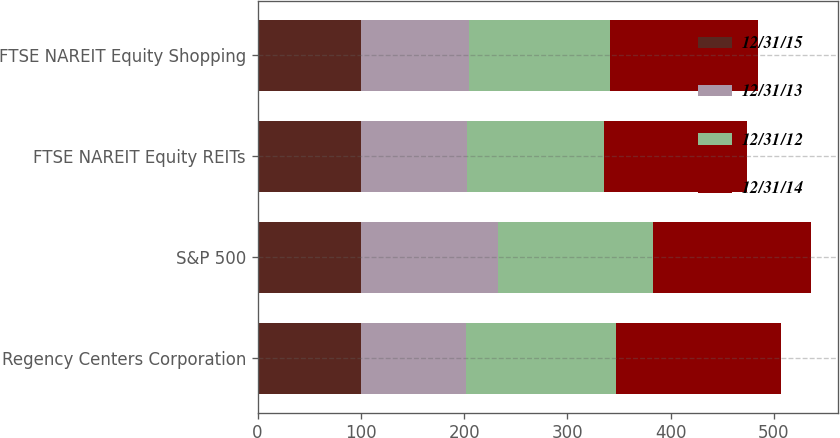<chart> <loc_0><loc_0><loc_500><loc_500><stacked_bar_chart><ecel><fcel>Regency Centers Corporation<fcel>S&P 500<fcel>FTSE NAREIT Equity REITs<fcel>FTSE NAREIT Equity Shopping<nl><fcel>12/31/15<fcel>100<fcel>100<fcel>100<fcel>100<nl><fcel>12/31/13<fcel>101.81<fcel>132.39<fcel>102.47<fcel>104.99<nl><fcel>12/31/12<fcel>145.11<fcel>150.51<fcel>133.35<fcel>136.45<nl><fcel>12/31/14<fcel>159.66<fcel>152.59<fcel>137.61<fcel>142.89<nl></chart> 